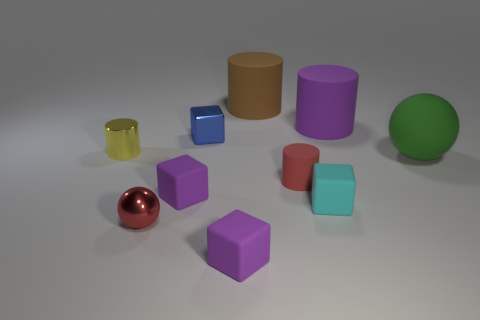Subtract all small matte blocks. How many blocks are left? 1 Subtract all gray cylinders. How many purple cubes are left? 2 Subtract all cyan blocks. How many blocks are left? 3 Subtract all cubes. How many objects are left? 6 Subtract 2 cylinders. How many cylinders are left? 2 Add 8 red metallic balls. How many red metallic balls are left? 9 Add 4 big red shiny things. How many big red shiny things exist? 4 Subtract 0 cyan cylinders. How many objects are left? 10 Subtract all cyan spheres. Subtract all gray cylinders. How many spheres are left? 2 Subtract all big purple matte cylinders. Subtract all small red things. How many objects are left? 7 